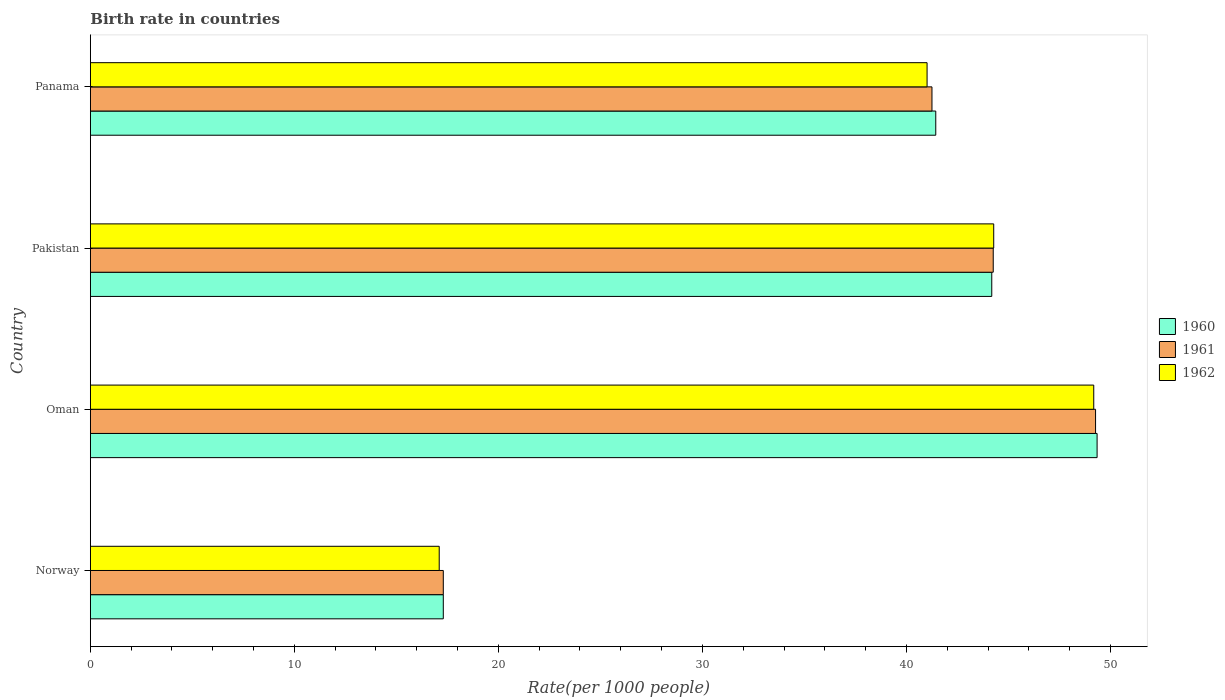How many different coloured bars are there?
Your response must be concise. 3. How many groups of bars are there?
Offer a very short reply. 4. Are the number of bars per tick equal to the number of legend labels?
Offer a very short reply. Yes. How many bars are there on the 4th tick from the top?
Your response must be concise. 3. How many bars are there on the 2nd tick from the bottom?
Provide a succinct answer. 3. What is the birth rate in 1961 in Oman?
Keep it short and to the point. 49.27. Across all countries, what is the maximum birth rate in 1962?
Ensure brevity in your answer.  49.18. Across all countries, what is the minimum birth rate in 1960?
Make the answer very short. 17.3. In which country was the birth rate in 1960 maximum?
Your response must be concise. Oman. What is the total birth rate in 1962 in the graph?
Keep it short and to the point. 151.58. What is the difference between the birth rate in 1962 in Oman and that in Panama?
Make the answer very short. 8.17. What is the difference between the birth rate in 1961 in Pakistan and the birth rate in 1962 in Norway?
Give a very brief answer. 27.16. What is the average birth rate in 1961 per country?
Provide a short and direct response. 38.02. What is the difference between the birth rate in 1961 and birth rate in 1960 in Pakistan?
Provide a succinct answer. 0.07. In how many countries, is the birth rate in 1961 greater than 4 ?
Give a very brief answer. 4. What is the ratio of the birth rate in 1960 in Norway to that in Oman?
Provide a short and direct response. 0.35. Is the birth rate in 1960 in Oman less than that in Panama?
Offer a terse response. No. Is the difference between the birth rate in 1961 in Norway and Oman greater than the difference between the birth rate in 1960 in Norway and Oman?
Provide a short and direct response. Yes. What is the difference between the highest and the second highest birth rate in 1961?
Give a very brief answer. 5.02. What is the difference between the highest and the lowest birth rate in 1961?
Ensure brevity in your answer.  31.97. In how many countries, is the birth rate in 1962 greater than the average birth rate in 1962 taken over all countries?
Provide a short and direct response. 3. What does the 3rd bar from the top in Pakistan represents?
Keep it short and to the point. 1960. How many bars are there?
Ensure brevity in your answer.  12. Are all the bars in the graph horizontal?
Provide a succinct answer. Yes. What is the difference between two consecutive major ticks on the X-axis?
Your answer should be very brief. 10. Does the graph contain any zero values?
Offer a very short reply. No. Does the graph contain grids?
Your answer should be compact. No. How many legend labels are there?
Your response must be concise. 3. What is the title of the graph?
Offer a terse response. Birth rate in countries. What is the label or title of the X-axis?
Offer a terse response. Rate(per 1000 people). What is the Rate(per 1000 people) in 1960 in Oman?
Your answer should be very brief. 49.35. What is the Rate(per 1000 people) in 1961 in Oman?
Your answer should be compact. 49.27. What is the Rate(per 1000 people) in 1962 in Oman?
Ensure brevity in your answer.  49.18. What is the Rate(per 1000 people) of 1960 in Pakistan?
Give a very brief answer. 44.18. What is the Rate(per 1000 people) of 1961 in Pakistan?
Provide a short and direct response. 44.26. What is the Rate(per 1000 people) of 1962 in Pakistan?
Your answer should be very brief. 44.28. What is the Rate(per 1000 people) of 1960 in Panama?
Keep it short and to the point. 41.44. What is the Rate(per 1000 people) in 1961 in Panama?
Offer a terse response. 41.25. What is the Rate(per 1000 people) of 1962 in Panama?
Your response must be concise. 41.01. Across all countries, what is the maximum Rate(per 1000 people) in 1960?
Make the answer very short. 49.35. Across all countries, what is the maximum Rate(per 1000 people) of 1961?
Offer a very short reply. 49.27. Across all countries, what is the maximum Rate(per 1000 people) in 1962?
Your answer should be compact. 49.18. Across all countries, what is the minimum Rate(per 1000 people) in 1960?
Give a very brief answer. 17.3. Across all countries, what is the minimum Rate(per 1000 people) of 1961?
Keep it short and to the point. 17.3. What is the total Rate(per 1000 people) in 1960 in the graph?
Provide a succinct answer. 152.27. What is the total Rate(per 1000 people) of 1961 in the graph?
Keep it short and to the point. 152.08. What is the total Rate(per 1000 people) in 1962 in the graph?
Your answer should be very brief. 151.58. What is the difference between the Rate(per 1000 people) of 1960 in Norway and that in Oman?
Keep it short and to the point. -32.05. What is the difference between the Rate(per 1000 people) of 1961 in Norway and that in Oman?
Provide a short and direct response. -31.97. What is the difference between the Rate(per 1000 people) of 1962 in Norway and that in Oman?
Provide a succinct answer. -32.08. What is the difference between the Rate(per 1000 people) of 1960 in Norway and that in Pakistan?
Make the answer very short. -26.88. What is the difference between the Rate(per 1000 people) of 1961 in Norway and that in Pakistan?
Provide a succinct answer. -26.96. What is the difference between the Rate(per 1000 people) of 1962 in Norway and that in Pakistan?
Your answer should be compact. -27.18. What is the difference between the Rate(per 1000 people) in 1960 in Norway and that in Panama?
Make the answer very short. -24.14. What is the difference between the Rate(per 1000 people) of 1961 in Norway and that in Panama?
Offer a very short reply. -23.95. What is the difference between the Rate(per 1000 people) in 1962 in Norway and that in Panama?
Offer a terse response. -23.91. What is the difference between the Rate(per 1000 people) in 1960 in Oman and that in Pakistan?
Your answer should be very brief. 5.16. What is the difference between the Rate(per 1000 people) in 1961 in Oman and that in Pakistan?
Offer a very short reply. 5.02. What is the difference between the Rate(per 1000 people) in 1962 in Oman and that in Pakistan?
Give a very brief answer. 4.9. What is the difference between the Rate(per 1000 people) in 1960 in Oman and that in Panama?
Your response must be concise. 7.91. What is the difference between the Rate(per 1000 people) of 1961 in Oman and that in Panama?
Provide a short and direct response. 8.02. What is the difference between the Rate(per 1000 people) of 1962 in Oman and that in Panama?
Give a very brief answer. 8.17. What is the difference between the Rate(per 1000 people) in 1960 in Pakistan and that in Panama?
Provide a short and direct response. 2.75. What is the difference between the Rate(per 1000 people) of 1961 in Pakistan and that in Panama?
Offer a very short reply. 3. What is the difference between the Rate(per 1000 people) in 1962 in Pakistan and that in Panama?
Give a very brief answer. 3.27. What is the difference between the Rate(per 1000 people) in 1960 in Norway and the Rate(per 1000 people) in 1961 in Oman?
Your response must be concise. -31.97. What is the difference between the Rate(per 1000 people) in 1960 in Norway and the Rate(per 1000 people) in 1962 in Oman?
Keep it short and to the point. -31.88. What is the difference between the Rate(per 1000 people) in 1961 in Norway and the Rate(per 1000 people) in 1962 in Oman?
Give a very brief answer. -31.88. What is the difference between the Rate(per 1000 people) of 1960 in Norway and the Rate(per 1000 people) of 1961 in Pakistan?
Keep it short and to the point. -26.96. What is the difference between the Rate(per 1000 people) of 1960 in Norway and the Rate(per 1000 people) of 1962 in Pakistan?
Make the answer very short. -26.98. What is the difference between the Rate(per 1000 people) in 1961 in Norway and the Rate(per 1000 people) in 1962 in Pakistan?
Your answer should be very brief. -26.98. What is the difference between the Rate(per 1000 people) in 1960 in Norway and the Rate(per 1000 people) in 1961 in Panama?
Make the answer very short. -23.95. What is the difference between the Rate(per 1000 people) of 1960 in Norway and the Rate(per 1000 people) of 1962 in Panama?
Offer a very short reply. -23.71. What is the difference between the Rate(per 1000 people) of 1961 in Norway and the Rate(per 1000 people) of 1962 in Panama?
Offer a terse response. -23.71. What is the difference between the Rate(per 1000 people) in 1960 in Oman and the Rate(per 1000 people) in 1961 in Pakistan?
Offer a very short reply. 5.09. What is the difference between the Rate(per 1000 people) of 1960 in Oman and the Rate(per 1000 people) of 1962 in Pakistan?
Give a very brief answer. 5.07. What is the difference between the Rate(per 1000 people) in 1961 in Oman and the Rate(per 1000 people) in 1962 in Pakistan?
Offer a terse response. 4.99. What is the difference between the Rate(per 1000 people) of 1960 in Oman and the Rate(per 1000 people) of 1961 in Panama?
Your answer should be compact. 8.09. What is the difference between the Rate(per 1000 people) in 1960 in Oman and the Rate(per 1000 people) in 1962 in Panama?
Make the answer very short. 8.33. What is the difference between the Rate(per 1000 people) in 1961 in Oman and the Rate(per 1000 people) in 1962 in Panama?
Give a very brief answer. 8.26. What is the difference between the Rate(per 1000 people) in 1960 in Pakistan and the Rate(per 1000 people) in 1961 in Panama?
Make the answer very short. 2.93. What is the difference between the Rate(per 1000 people) in 1960 in Pakistan and the Rate(per 1000 people) in 1962 in Panama?
Offer a very short reply. 3.17. What is the difference between the Rate(per 1000 people) in 1961 in Pakistan and the Rate(per 1000 people) in 1962 in Panama?
Keep it short and to the point. 3.24. What is the average Rate(per 1000 people) of 1960 per country?
Ensure brevity in your answer.  38.07. What is the average Rate(per 1000 people) in 1961 per country?
Offer a very short reply. 38.02. What is the average Rate(per 1000 people) of 1962 per country?
Give a very brief answer. 37.89. What is the difference between the Rate(per 1000 people) of 1960 and Rate(per 1000 people) of 1961 in Norway?
Your response must be concise. 0. What is the difference between the Rate(per 1000 people) in 1960 and Rate(per 1000 people) in 1962 in Norway?
Keep it short and to the point. 0.2. What is the difference between the Rate(per 1000 people) in 1961 and Rate(per 1000 people) in 1962 in Norway?
Your response must be concise. 0.2. What is the difference between the Rate(per 1000 people) in 1960 and Rate(per 1000 people) in 1961 in Oman?
Keep it short and to the point. 0.07. What is the difference between the Rate(per 1000 people) of 1960 and Rate(per 1000 people) of 1962 in Oman?
Provide a succinct answer. 0.16. What is the difference between the Rate(per 1000 people) of 1961 and Rate(per 1000 people) of 1962 in Oman?
Keep it short and to the point. 0.09. What is the difference between the Rate(per 1000 people) in 1960 and Rate(per 1000 people) in 1961 in Pakistan?
Ensure brevity in your answer.  -0.07. What is the difference between the Rate(per 1000 people) in 1960 and Rate(per 1000 people) in 1962 in Pakistan?
Your answer should be compact. -0.1. What is the difference between the Rate(per 1000 people) of 1961 and Rate(per 1000 people) of 1962 in Pakistan?
Offer a very short reply. -0.02. What is the difference between the Rate(per 1000 people) of 1960 and Rate(per 1000 people) of 1961 in Panama?
Your answer should be very brief. 0.19. What is the difference between the Rate(per 1000 people) in 1960 and Rate(per 1000 people) in 1962 in Panama?
Your response must be concise. 0.43. What is the difference between the Rate(per 1000 people) of 1961 and Rate(per 1000 people) of 1962 in Panama?
Make the answer very short. 0.24. What is the ratio of the Rate(per 1000 people) of 1960 in Norway to that in Oman?
Your answer should be compact. 0.35. What is the ratio of the Rate(per 1000 people) of 1961 in Norway to that in Oman?
Offer a terse response. 0.35. What is the ratio of the Rate(per 1000 people) in 1962 in Norway to that in Oman?
Provide a short and direct response. 0.35. What is the ratio of the Rate(per 1000 people) in 1960 in Norway to that in Pakistan?
Give a very brief answer. 0.39. What is the ratio of the Rate(per 1000 people) of 1961 in Norway to that in Pakistan?
Your response must be concise. 0.39. What is the ratio of the Rate(per 1000 people) of 1962 in Norway to that in Pakistan?
Ensure brevity in your answer.  0.39. What is the ratio of the Rate(per 1000 people) in 1960 in Norway to that in Panama?
Provide a succinct answer. 0.42. What is the ratio of the Rate(per 1000 people) in 1961 in Norway to that in Panama?
Your answer should be very brief. 0.42. What is the ratio of the Rate(per 1000 people) of 1962 in Norway to that in Panama?
Give a very brief answer. 0.42. What is the ratio of the Rate(per 1000 people) in 1960 in Oman to that in Pakistan?
Provide a short and direct response. 1.12. What is the ratio of the Rate(per 1000 people) in 1961 in Oman to that in Pakistan?
Offer a very short reply. 1.11. What is the ratio of the Rate(per 1000 people) in 1962 in Oman to that in Pakistan?
Offer a terse response. 1.11. What is the ratio of the Rate(per 1000 people) in 1960 in Oman to that in Panama?
Your response must be concise. 1.19. What is the ratio of the Rate(per 1000 people) of 1961 in Oman to that in Panama?
Offer a terse response. 1.19. What is the ratio of the Rate(per 1000 people) of 1962 in Oman to that in Panama?
Offer a very short reply. 1.2. What is the ratio of the Rate(per 1000 people) of 1960 in Pakistan to that in Panama?
Your response must be concise. 1.07. What is the ratio of the Rate(per 1000 people) in 1961 in Pakistan to that in Panama?
Keep it short and to the point. 1.07. What is the ratio of the Rate(per 1000 people) in 1962 in Pakistan to that in Panama?
Your answer should be compact. 1.08. What is the difference between the highest and the second highest Rate(per 1000 people) of 1960?
Make the answer very short. 5.16. What is the difference between the highest and the second highest Rate(per 1000 people) of 1961?
Provide a succinct answer. 5.02. What is the difference between the highest and the second highest Rate(per 1000 people) of 1962?
Provide a succinct answer. 4.9. What is the difference between the highest and the lowest Rate(per 1000 people) of 1960?
Ensure brevity in your answer.  32.05. What is the difference between the highest and the lowest Rate(per 1000 people) in 1961?
Make the answer very short. 31.97. What is the difference between the highest and the lowest Rate(per 1000 people) in 1962?
Ensure brevity in your answer.  32.08. 